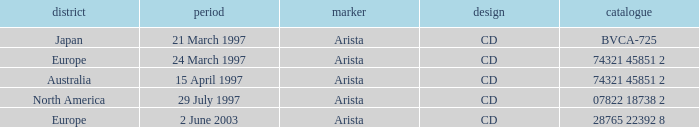What Label has the Region of Australia? Arista. 